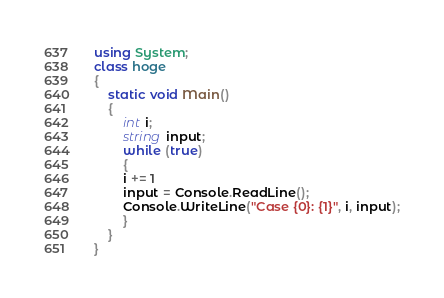<code> <loc_0><loc_0><loc_500><loc_500><_C#_>using System;
class hoge
{
    static void Main()
    {
        int i;
        string input;
        while (true)
        {
        i += 1
        input = Console.ReadLine();
        Console.WriteLine("Case {0}: {1}", i, input);
        }
    }
}</code> 